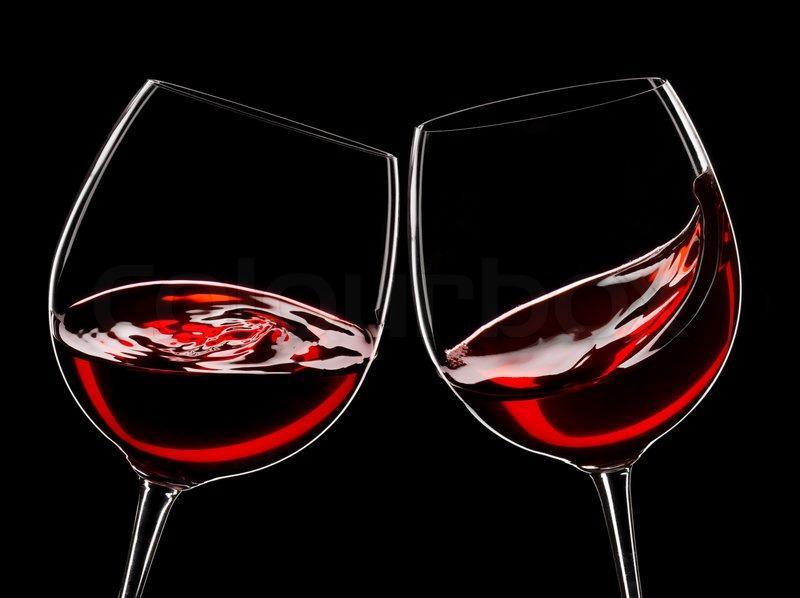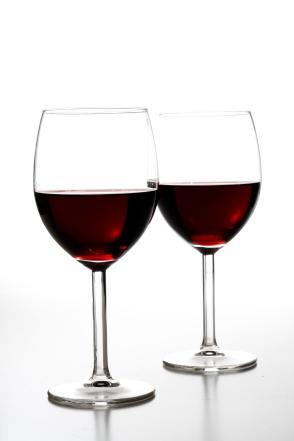The first image is the image on the left, the second image is the image on the right. Assess this claim about the two images: "Two glasses are angled toward each other in one of the images.". Correct or not? Answer yes or no. Yes. The first image is the image on the left, the second image is the image on the right. Analyze the images presented: Is the assertion "There is one pair of overlapping glasses containing level liquids, and one pair of glasses that do not overlap." valid? Answer yes or no. Yes. 